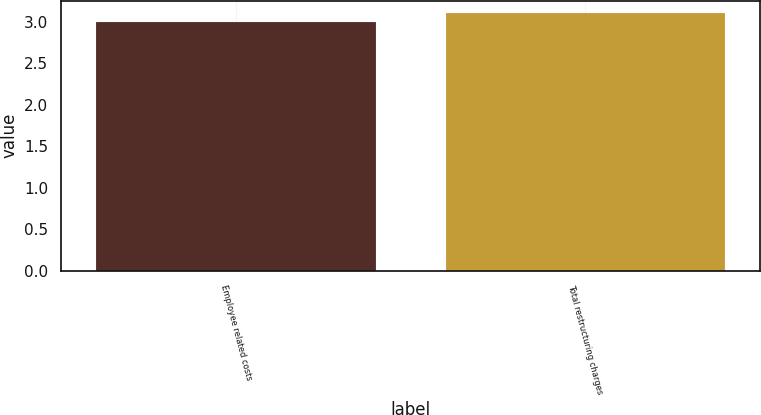Convert chart. <chart><loc_0><loc_0><loc_500><loc_500><bar_chart><fcel>Employee related costs<fcel>Total restructuring charges<nl><fcel>3<fcel>3.1<nl></chart> 